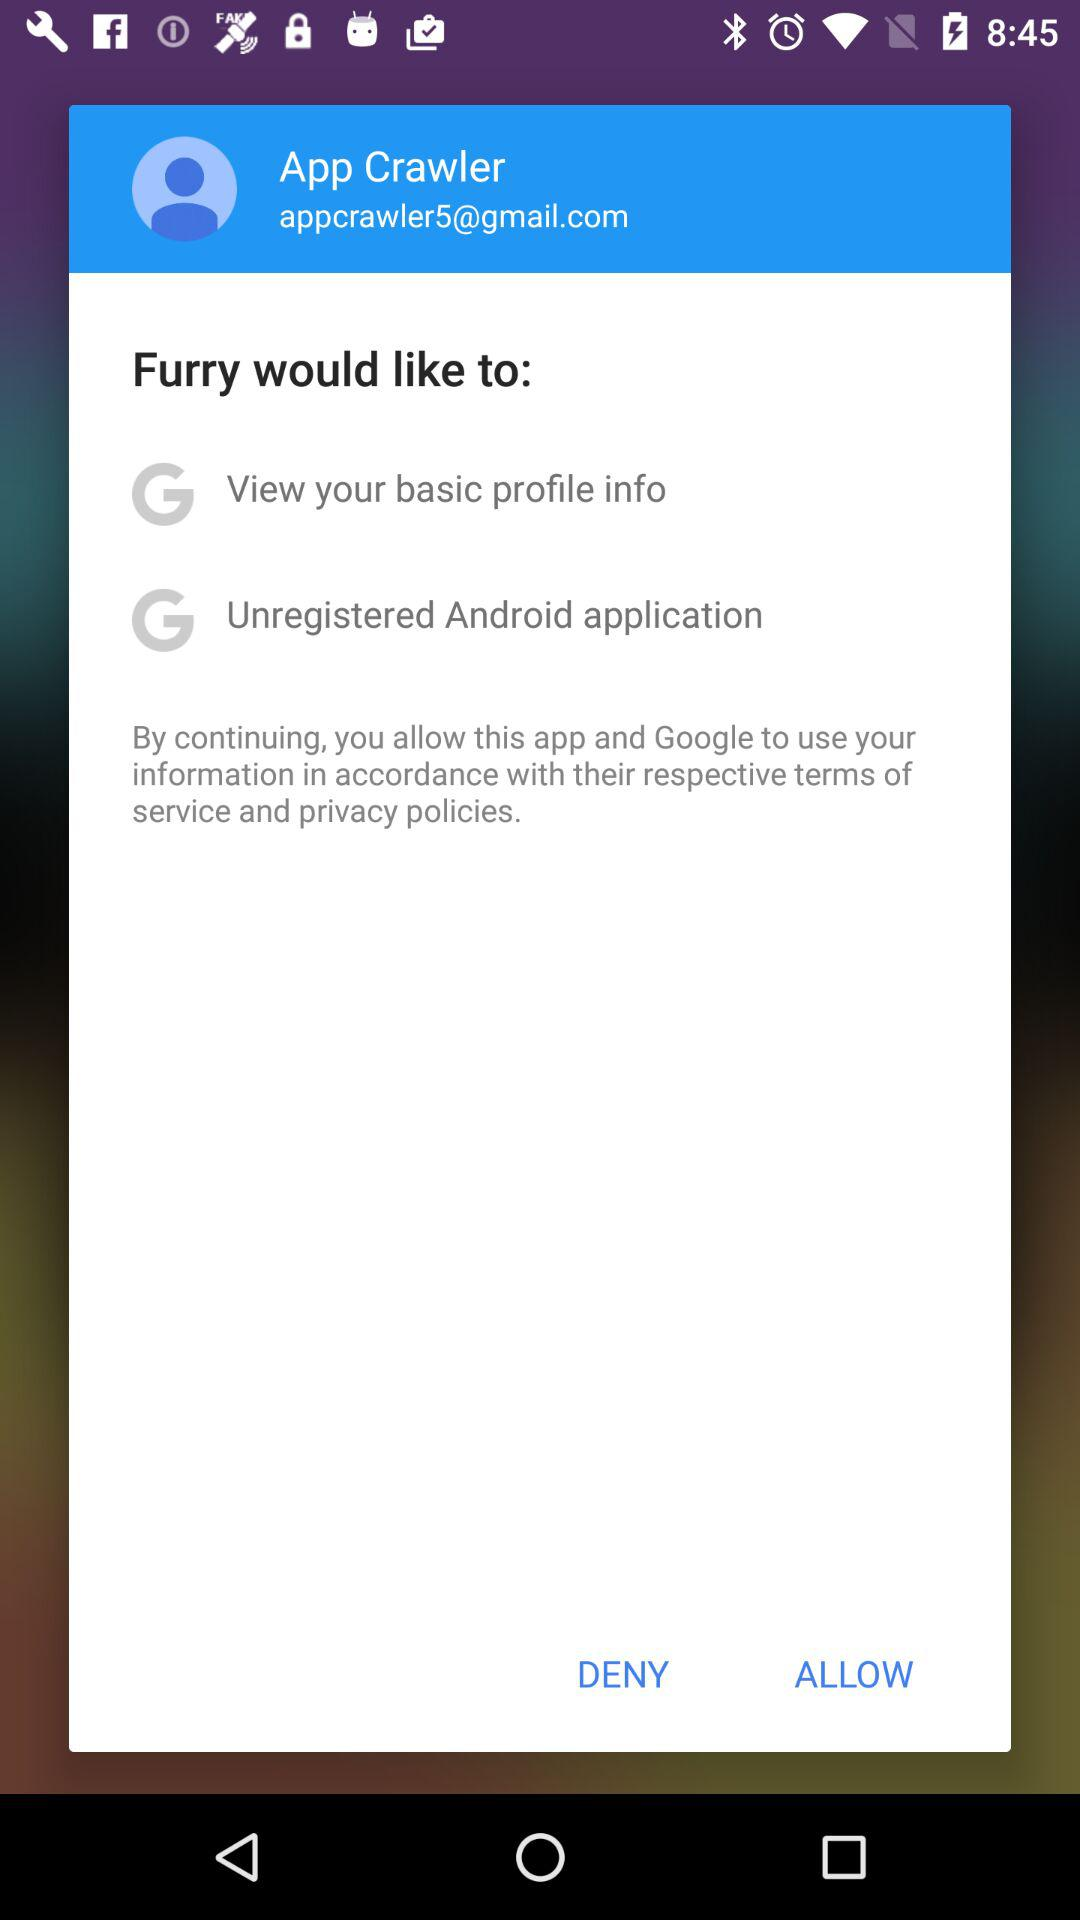Which things would "Furry" like to access? "Furry" would like to "View your basic profile info" and "Unregistered Android application". 